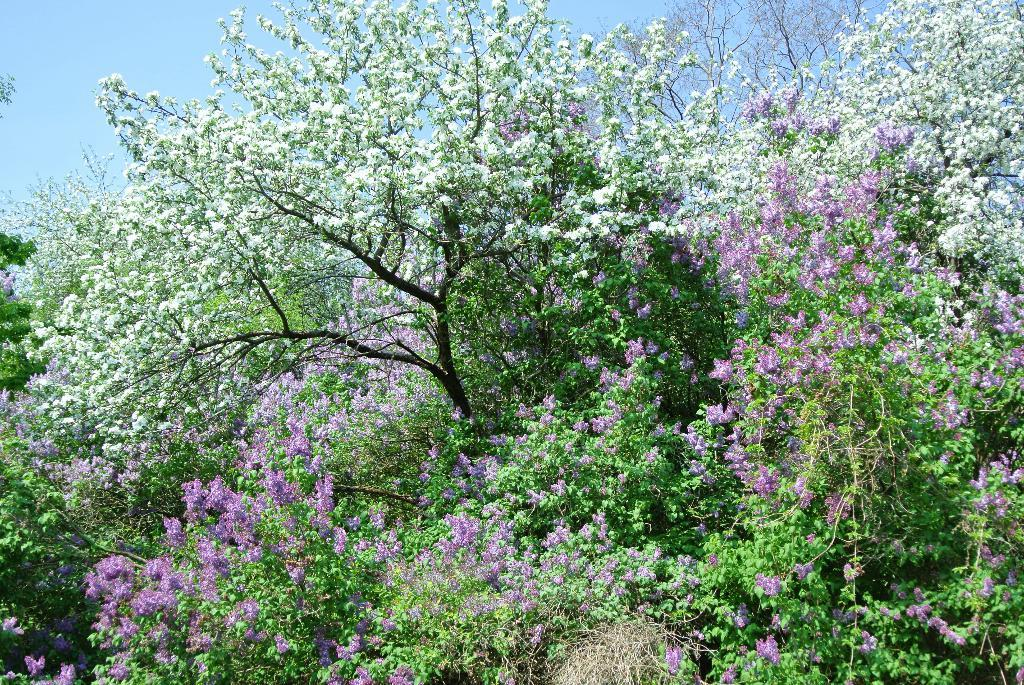What type of plants can be seen in the image? There are flowers in the image. Where are the flowers located? The flowers are on the branches of trees. What type of toothpaste is being used to water the flowers in the image? There is no toothpaste present in the image, and toothpaste is not used for watering flowers. 